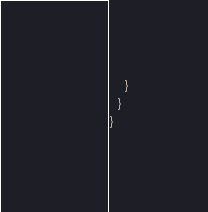Convert code to text. <code><loc_0><loc_0><loc_500><loc_500><_Kotlin_>    }
  }
}
</code> 